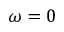<formula> <loc_0><loc_0><loc_500><loc_500>\omega = 0</formula> 